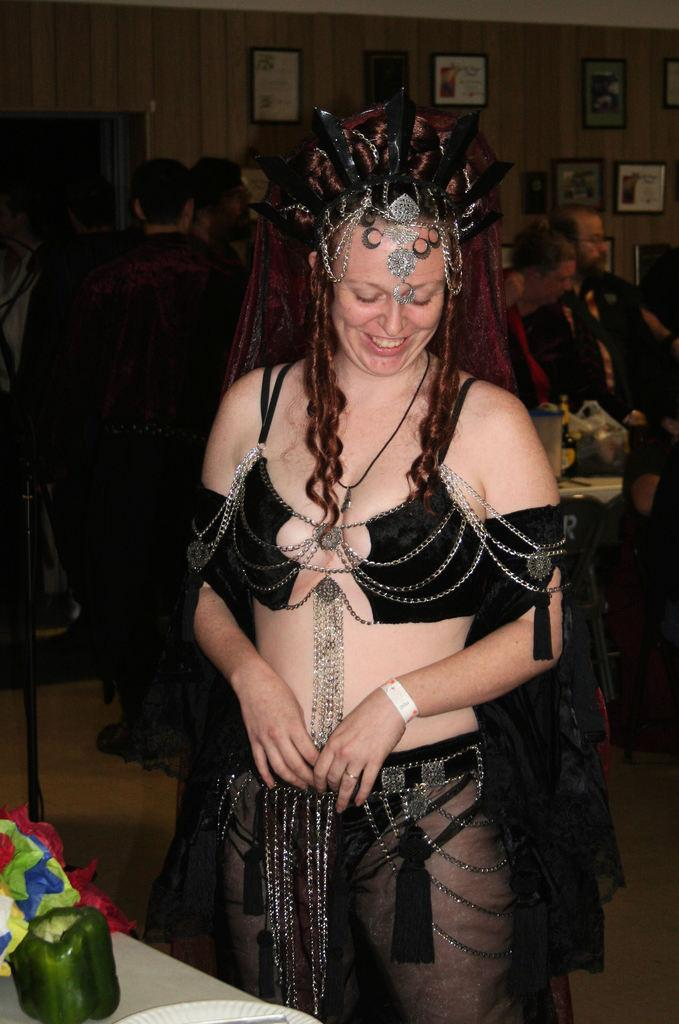Where are the children playing in the image? The transcript does not specify the location of the park, so we cannot definitively answer this question. What season is depicted in the image? The transcript does not mention any seasonal details, so we cannot definitively answer this question. What object might the children be using to drink water in the image? The transcript does not mention any cups or drinking objects, so we cannot definitively answer this question. What type of downtown scene can be seen in the image? The transcript does not mention any downtown scene, so we cannot definitively answer this question. 